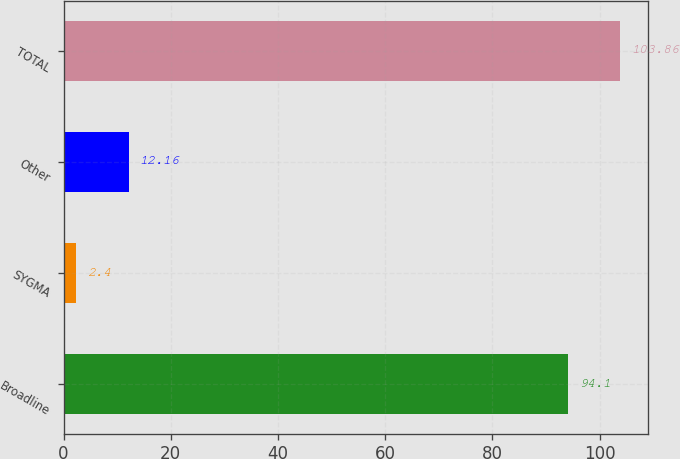Convert chart. <chart><loc_0><loc_0><loc_500><loc_500><bar_chart><fcel>Broadline<fcel>SYGMA<fcel>Other<fcel>TOTAL<nl><fcel>94.1<fcel>2.4<fcel>12.16<fcel>103.86<nl></chart> 